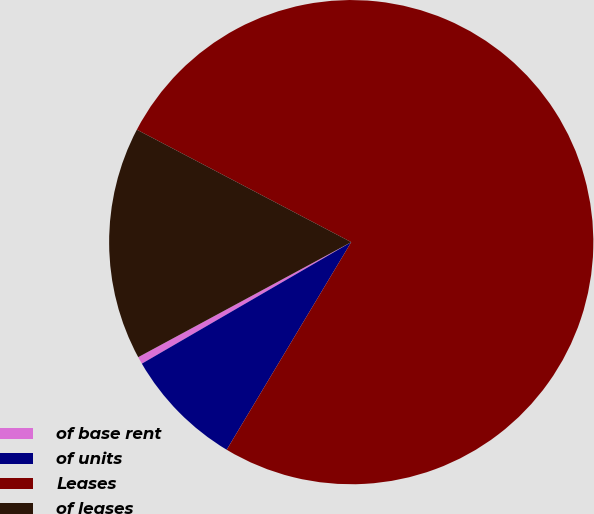Convert chart to OTSL. <chart><loc_0><loc_0><loc_500><loc_500><pie_chart><fcel>of base rent<fcel>of units<fcel>Leases<fcel>of leases<nl><fcel>0.49%<fcel>8.03%<fcel>75.91%<fcel>15.57%<nl></chart> 